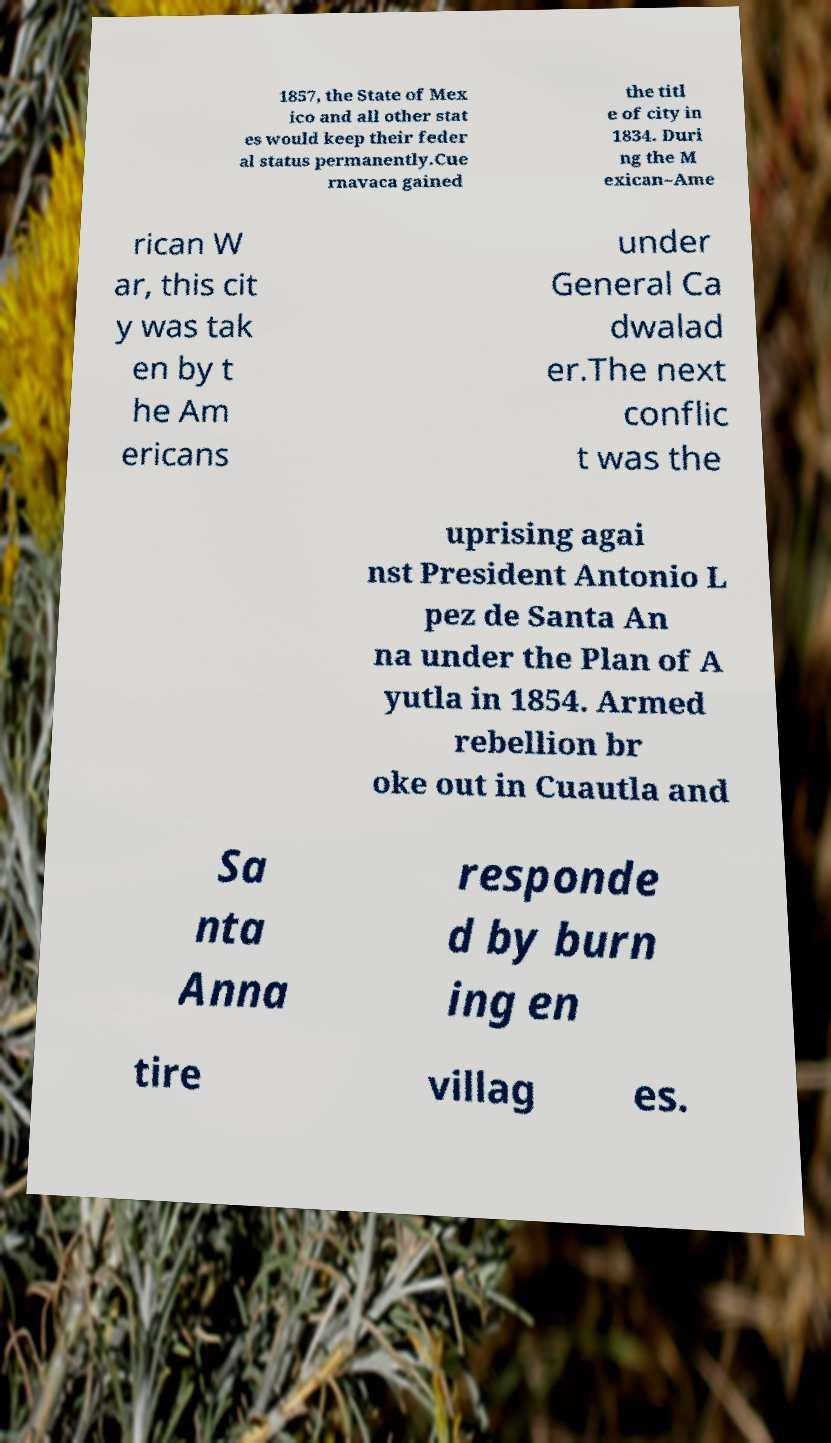Can you read and provide the text displayed in the image?This photo seems to have some interesting text. Can you extract and type it out for me? 1857, the State of Mex ico and all other stat es would keep their feder al status permanently.Cue rnavaca gained the titl e of city in 1834. Duri ng the M exican–Ame rican W ar, this cit y was tak en by t he Am ericans under General Ca dwalad er.The next conflic t was the uprising agai nst President Antonio L pez de Santa An na under the Plan of A yutla in 1854. Armed rebellion br oke out in Cuautla and Sa nta Anna responde d by burn ing en tire villag es. 